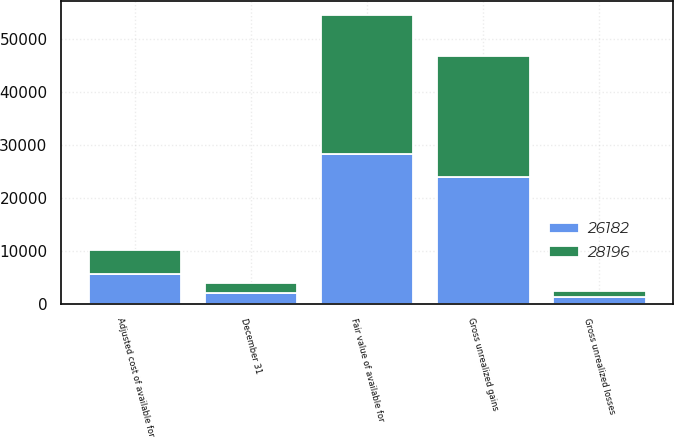Convert chart to OTSL. <chart><loc_0><loc_0><loc_500><loc_500><stacked_bar_chart><ecel><fcel>December 31<fcel>Adjusted cost of available for<fcel>Gross unrealized gains<fcel>Gross unrealized losses<fcel>Fair value of available for<nl><fcel>26182<fcel>2007<fcel>5626<fcel>23947<fcel>1377<fcel>28196<nl><fcel>28196<fcel>2006<fcel>4445<fcel>22849<fcel>1112<fcel>26182<nl></chart> 